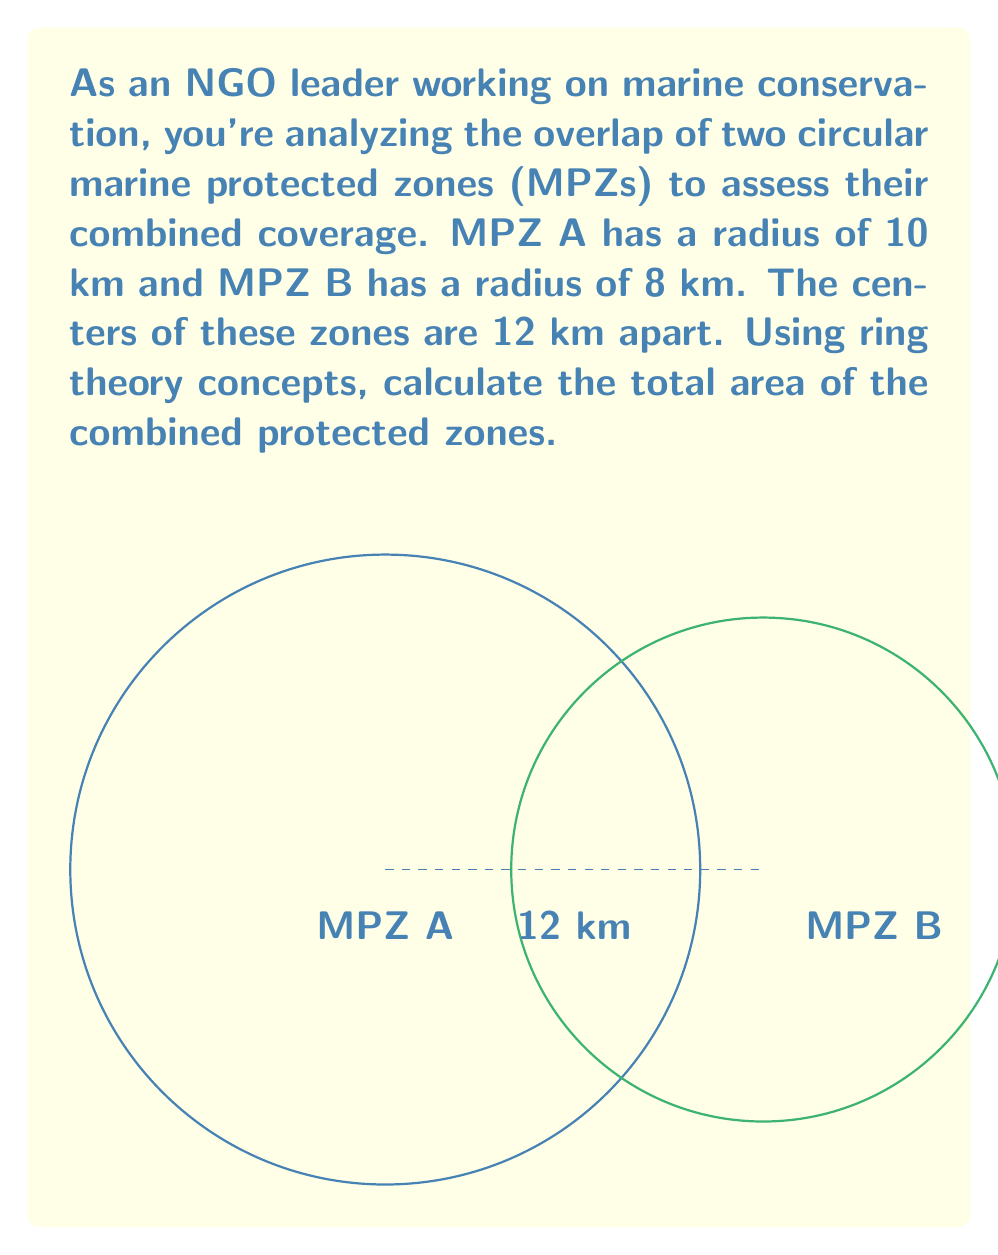Help me with this question. Let's approach this step-by-step using ring theory concepts:

1) First, we need to calculate the area of overlap between the two circles. This can be done using the formula for the area of intersection of two circles:

   $$A_{overlap} = r_1^2 \arccos(\frac{d^2 + r_1^2 - r_2^2}{2dr_1}) + r_2^2 \arccos(\frac{d^2 + r_2^2 - r_1^2}{2dr_2}) - \frac{1}{2}\sqrt{(-d+r_1+r_2)(d+r_1-r_2)(d-r_1+r_2)(d+r_1+r_2)}$$

   Where $r_1$ and $r_2$ are the radii of the circles and $d$ is the distance between their centers.

2) Plugging in our values:
   $r_1 = 10$, $r_2 = 8$, $d = 12$

3) Calculating:
   $$A_{overlap} = 100 \arccos(\frac{144 + 100 - 64}{240}) + 64 \arccos(\frac{144 + 64 - 100}{192}) - \frac{1}{2}\sqrt{(-12+10+8)(12+10-8)(12-10+8)(12+10+8)}$$

4) This evaluates to approximately 43.98 km².

5) Now, we need to calculate the total area covered by both MPZs. In ring theory, this is equivalent to the sum of the areas of both circles minus their intersection:

   $$A_{total} = \pi r_1^2 + \pi r_2^2 - A_{overlap}$$

6) Calculating:
   $$A_{total} = \pi (10^2) + \pi (8^2) - 43.98$$
   $$A_{total} = 314.16 + 201.06 - 43.98 = 471.24 \text{ km}^2$$

Therefore, the total area of the combined protected zones is approximately 471.24 km².
Answer: 471.24 km² 